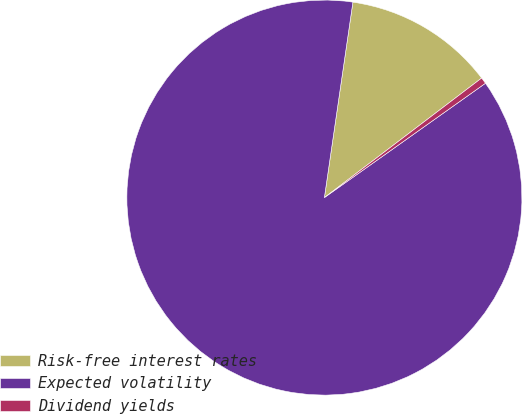Convert chart to OTSL. <chart><loc_0><loc_0><loc_500><loc_500><pie_chart><fcel>Risk-free interest rates<fcel>Expected volatility<fcel>Dividend yields<nl><fcel>12.35%<fcel>87.13%<fcel>0.52%<nl></chart> 